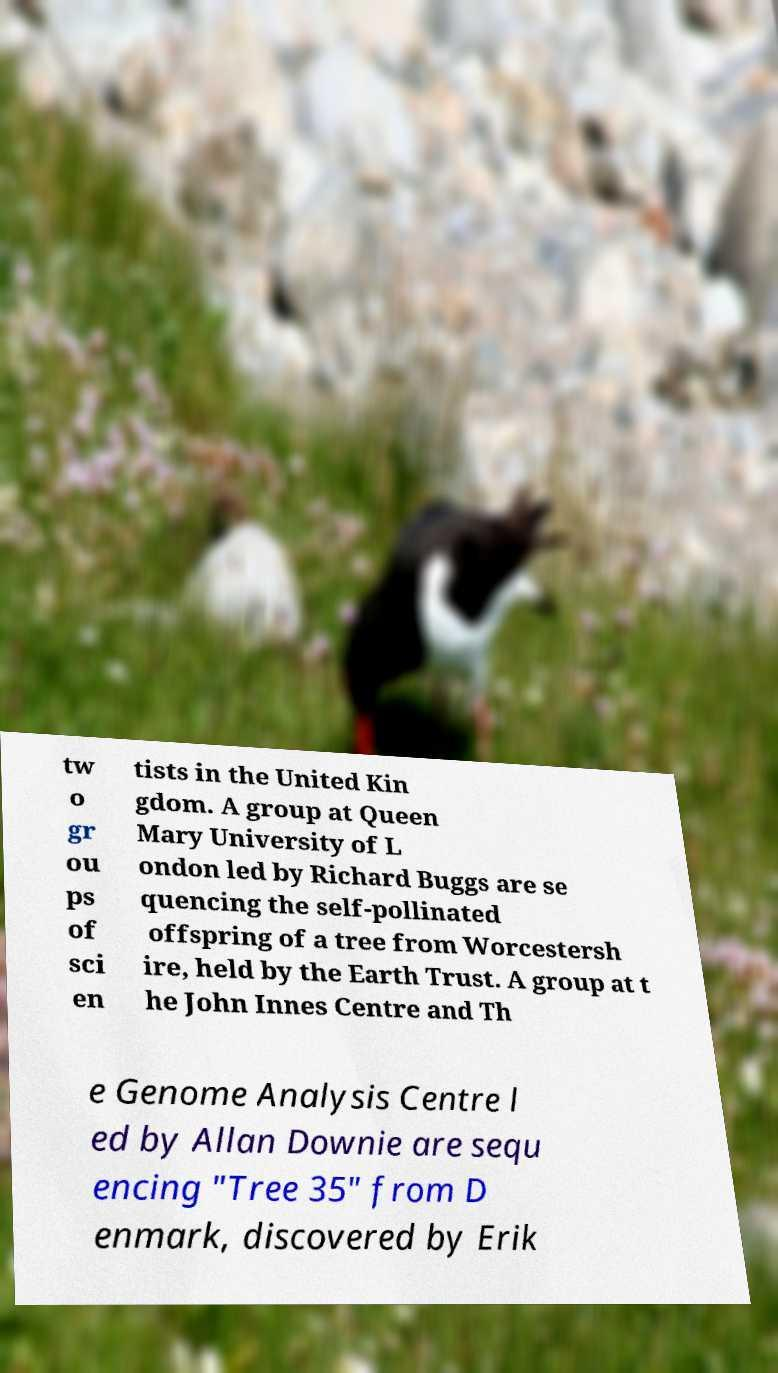Please read and relay the text visible in this image. What does it say? tw o gr ou ps of sci en tists in the United Kin gdom. A group at Queen Mary University of L ondon led by Richard Buggs are se quencing the self-pollinated offspring of a tree from Worcestersh ire, held by the Earth Trust. A group at t he John Innes Centre and Th e Genome Analysis Centre l ed by Allan Downie are sequ encing "Tree 35" from D enmark, discovered by Erik 